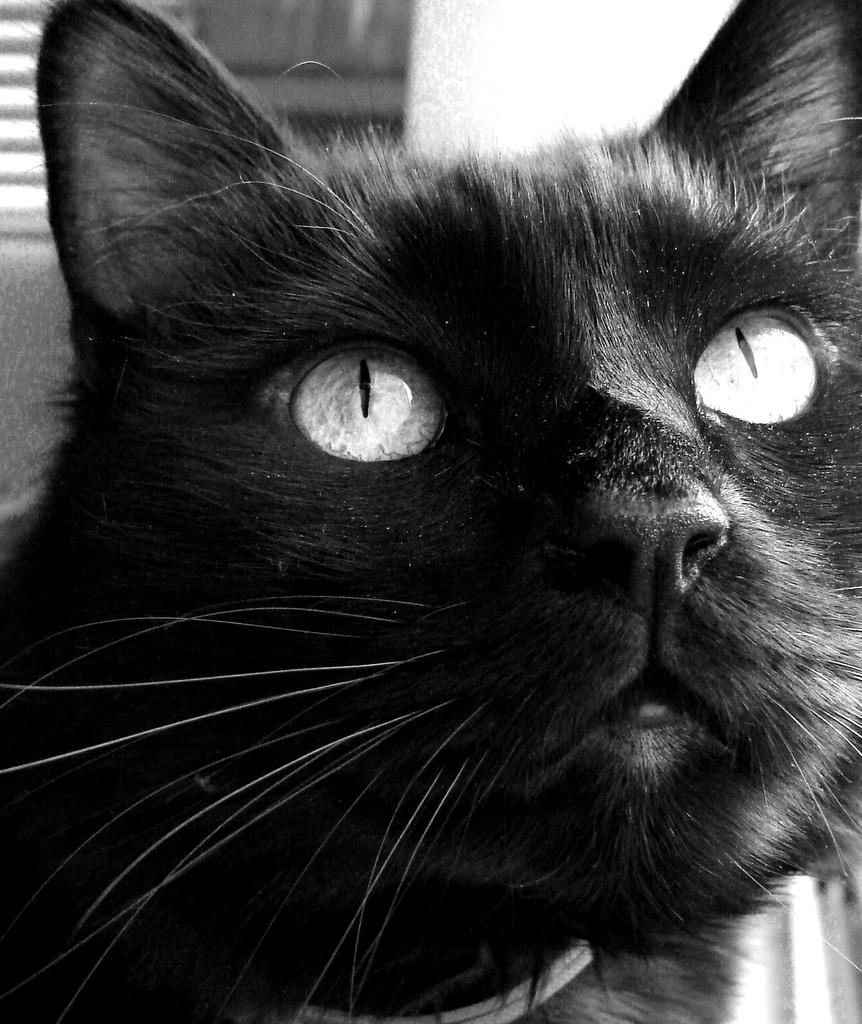What type of animal is in the image? There is a black color cat in the image. Where is the cat located in the image? The cat is in the middle of the image. What can be seen in the background of the image? There is a wall in the background of the image. What month is depicted on the card in the image? There is no card present in the image, so it is not possible to determine the month depicted on it. 